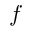Convert formula to latex. <formula><loc_0><loc_0><loc_500><loc_500>f</formula> 